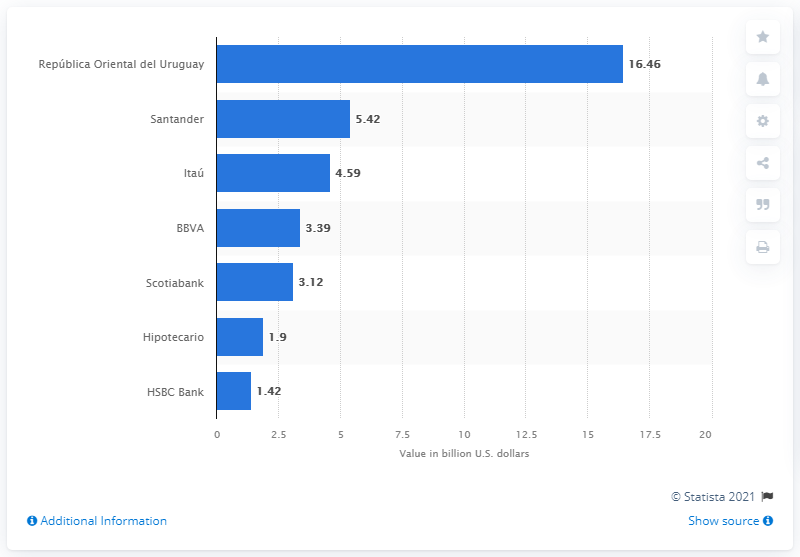List a handful of essential elements in this visual. Santander was the second largest bank in Uruguay as of June 2017. Banco de la República Oriental del Uruguay's total assets were 16.46.. 